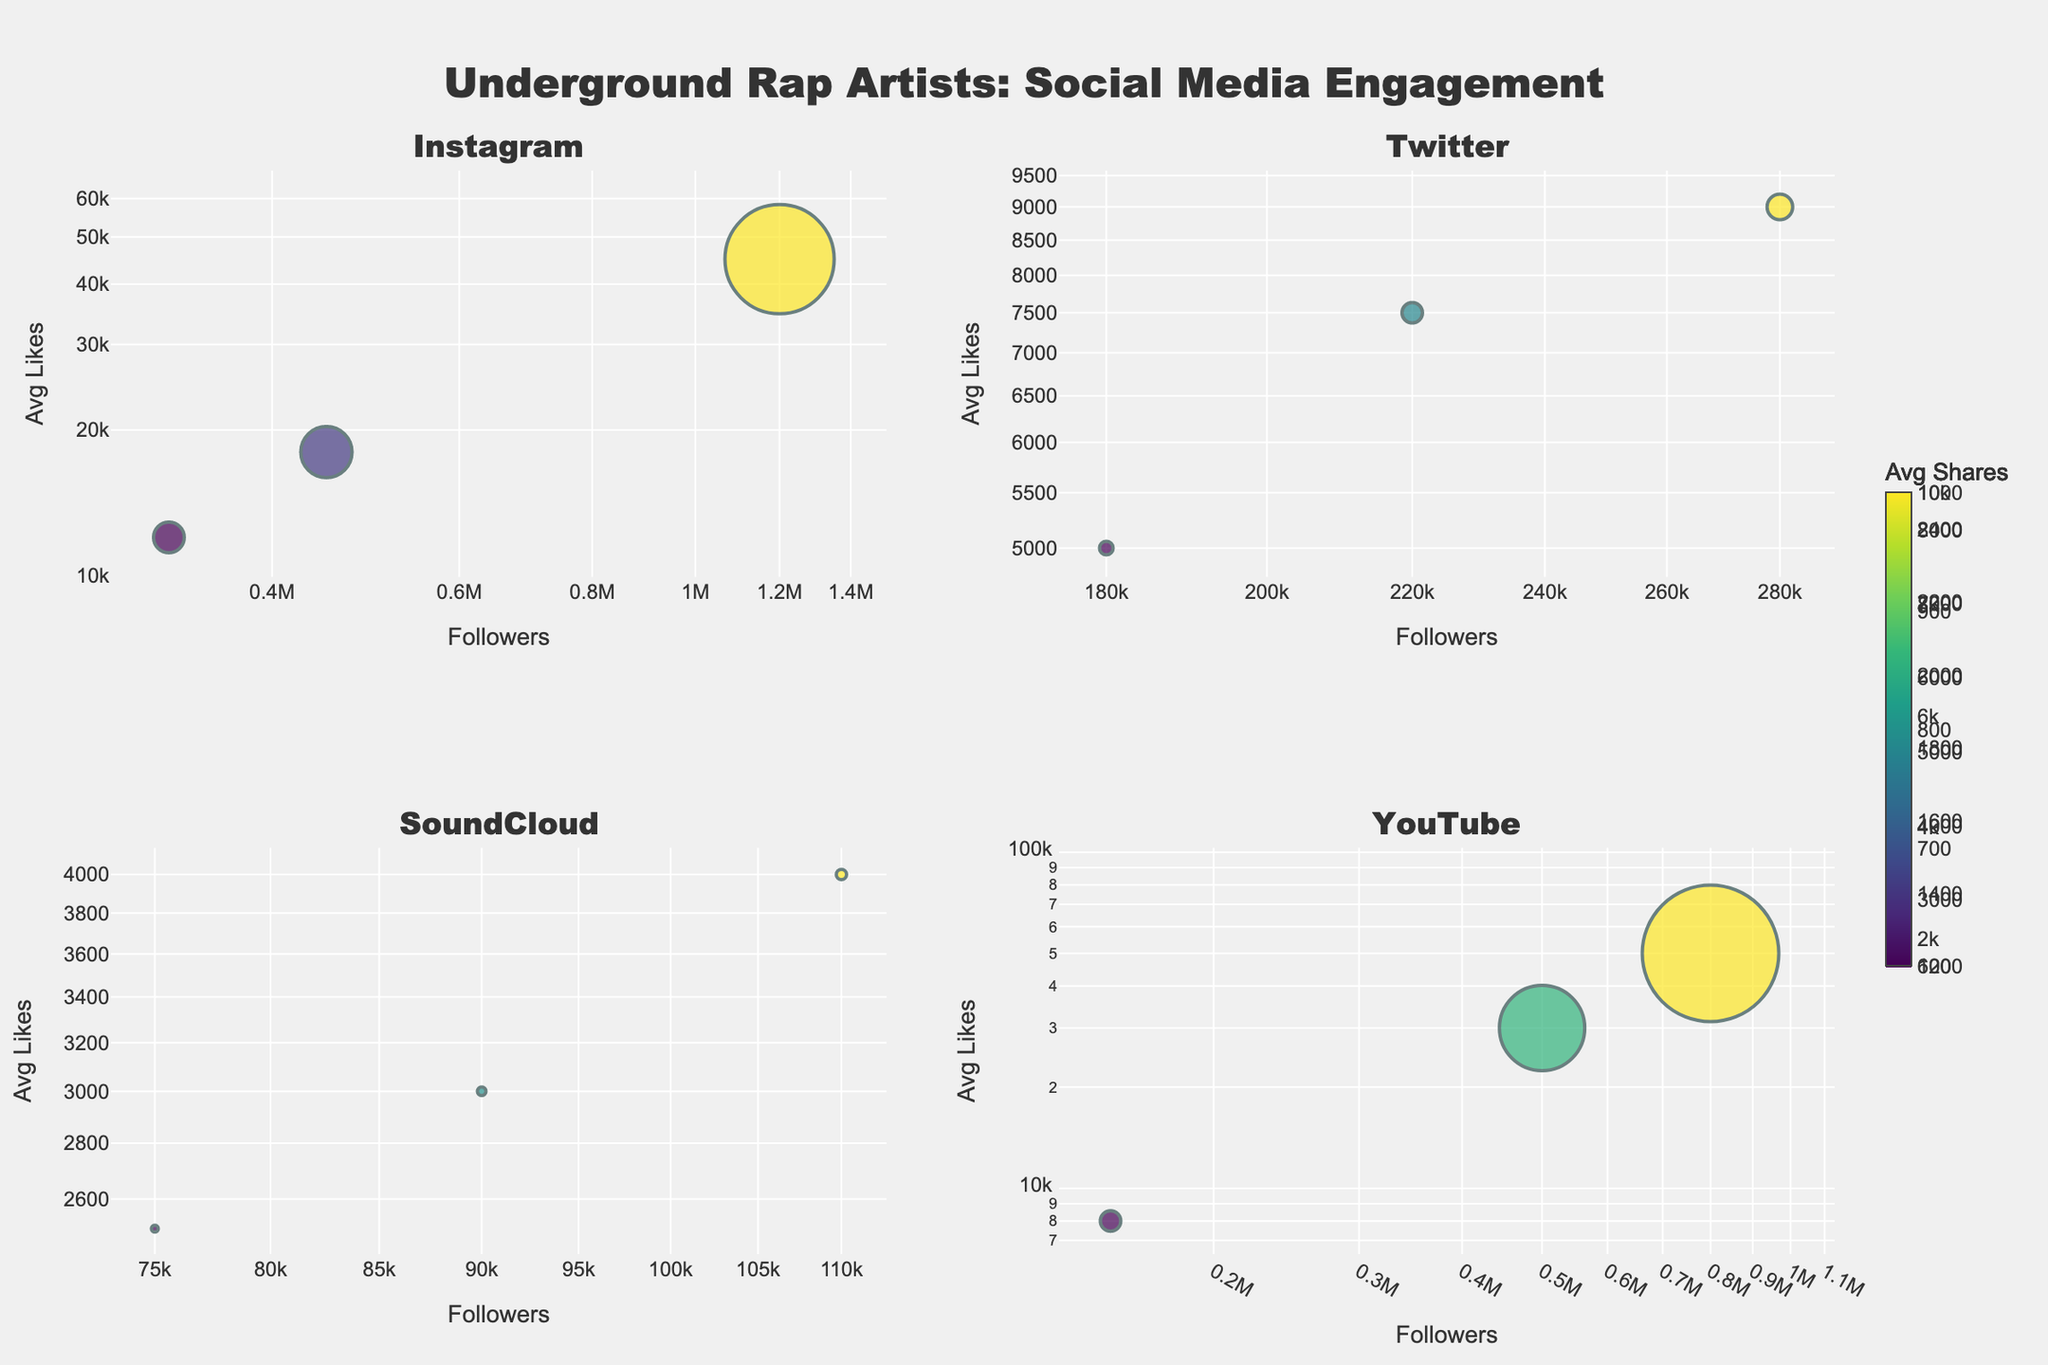Which platform has the artist with the highest number of followers? The platform with the highest number of followers can be identified by observing the largest x-value on the chart. Earl Sweatshirt has the highest number of followers on YouTube with 800,000 followers.
Answer: YouTube Which artist has the highest average likes on Instagram? Check the y-values for the Instagram subplot. Griselda has the highest average likes with 45,000.
Answer: Griselda On which platform does the artist with the smallest bubble size appear? The smallest bubbles indicate the smallest average comments. On SoundCloud, Navy Blue has the smallest bubble size.
Answer: SoundCloud What is the relationship between the number of followers and average likes on Twitter? By examining the Twitter subplot, we can see that as the number of followers increases, the average likes also generally increase. This indicates a positive correlation.
Answer: Positive correlation Which artist on Instagram has less than 500,000 followers but more than 10,000 average likes? Look for a point on Instagram's subplot with an x-value less than 500,000 and a y-value greater than 10,000. Roc Marciano fits this criterion.
Answer: Roc Marciano How does Aesop Rock's average likes compare to Quelle Chris's on YouTube? By observing the y-values on the YouTube subplot, Aesop Rock has 30,000 average likes whereas Quelle Chris has 8,000 average likes. Aesop Rock has significantly higher average likes.
Answer: Aesop Rock has more Which platform shows the most variation in bubble size (avg comments)? Compare the size of the bubbles across all subplots. Twitter and Instagram show more variation in bubble sizes, indicating more variation in average comments on these platforms. Between them, Instagram seems to have a wider range of sizes.
Answer: Instagram What color represents average shares greater than 8,000? The color range is indicated by a color bar titled 'Avg Shares' using the Viridis scale. Colors towards the lighter end of the scale typically represent higher averages, and greenish colors represent shares greater than 8,000.
Answer: Greenish How do the number of followers of Mach-Hommy on Twitter compare to the followers of Ka on the same platform? Observing the x-values on the Twitter subplot, Mach-Hommy has 280,000 followers while Ka has 180,000 followers. Mach-Hommy has more followers than Ka.
Answer: Mach-Hommy has more Do artists with higher average shares generally have higher average comments? Look at the overall color and bubble size relationships. Higher color values (more shares) often coincide with somewhat larger bubbles (more comments), indicating a positive correlation.
Answer: Yes, generally 